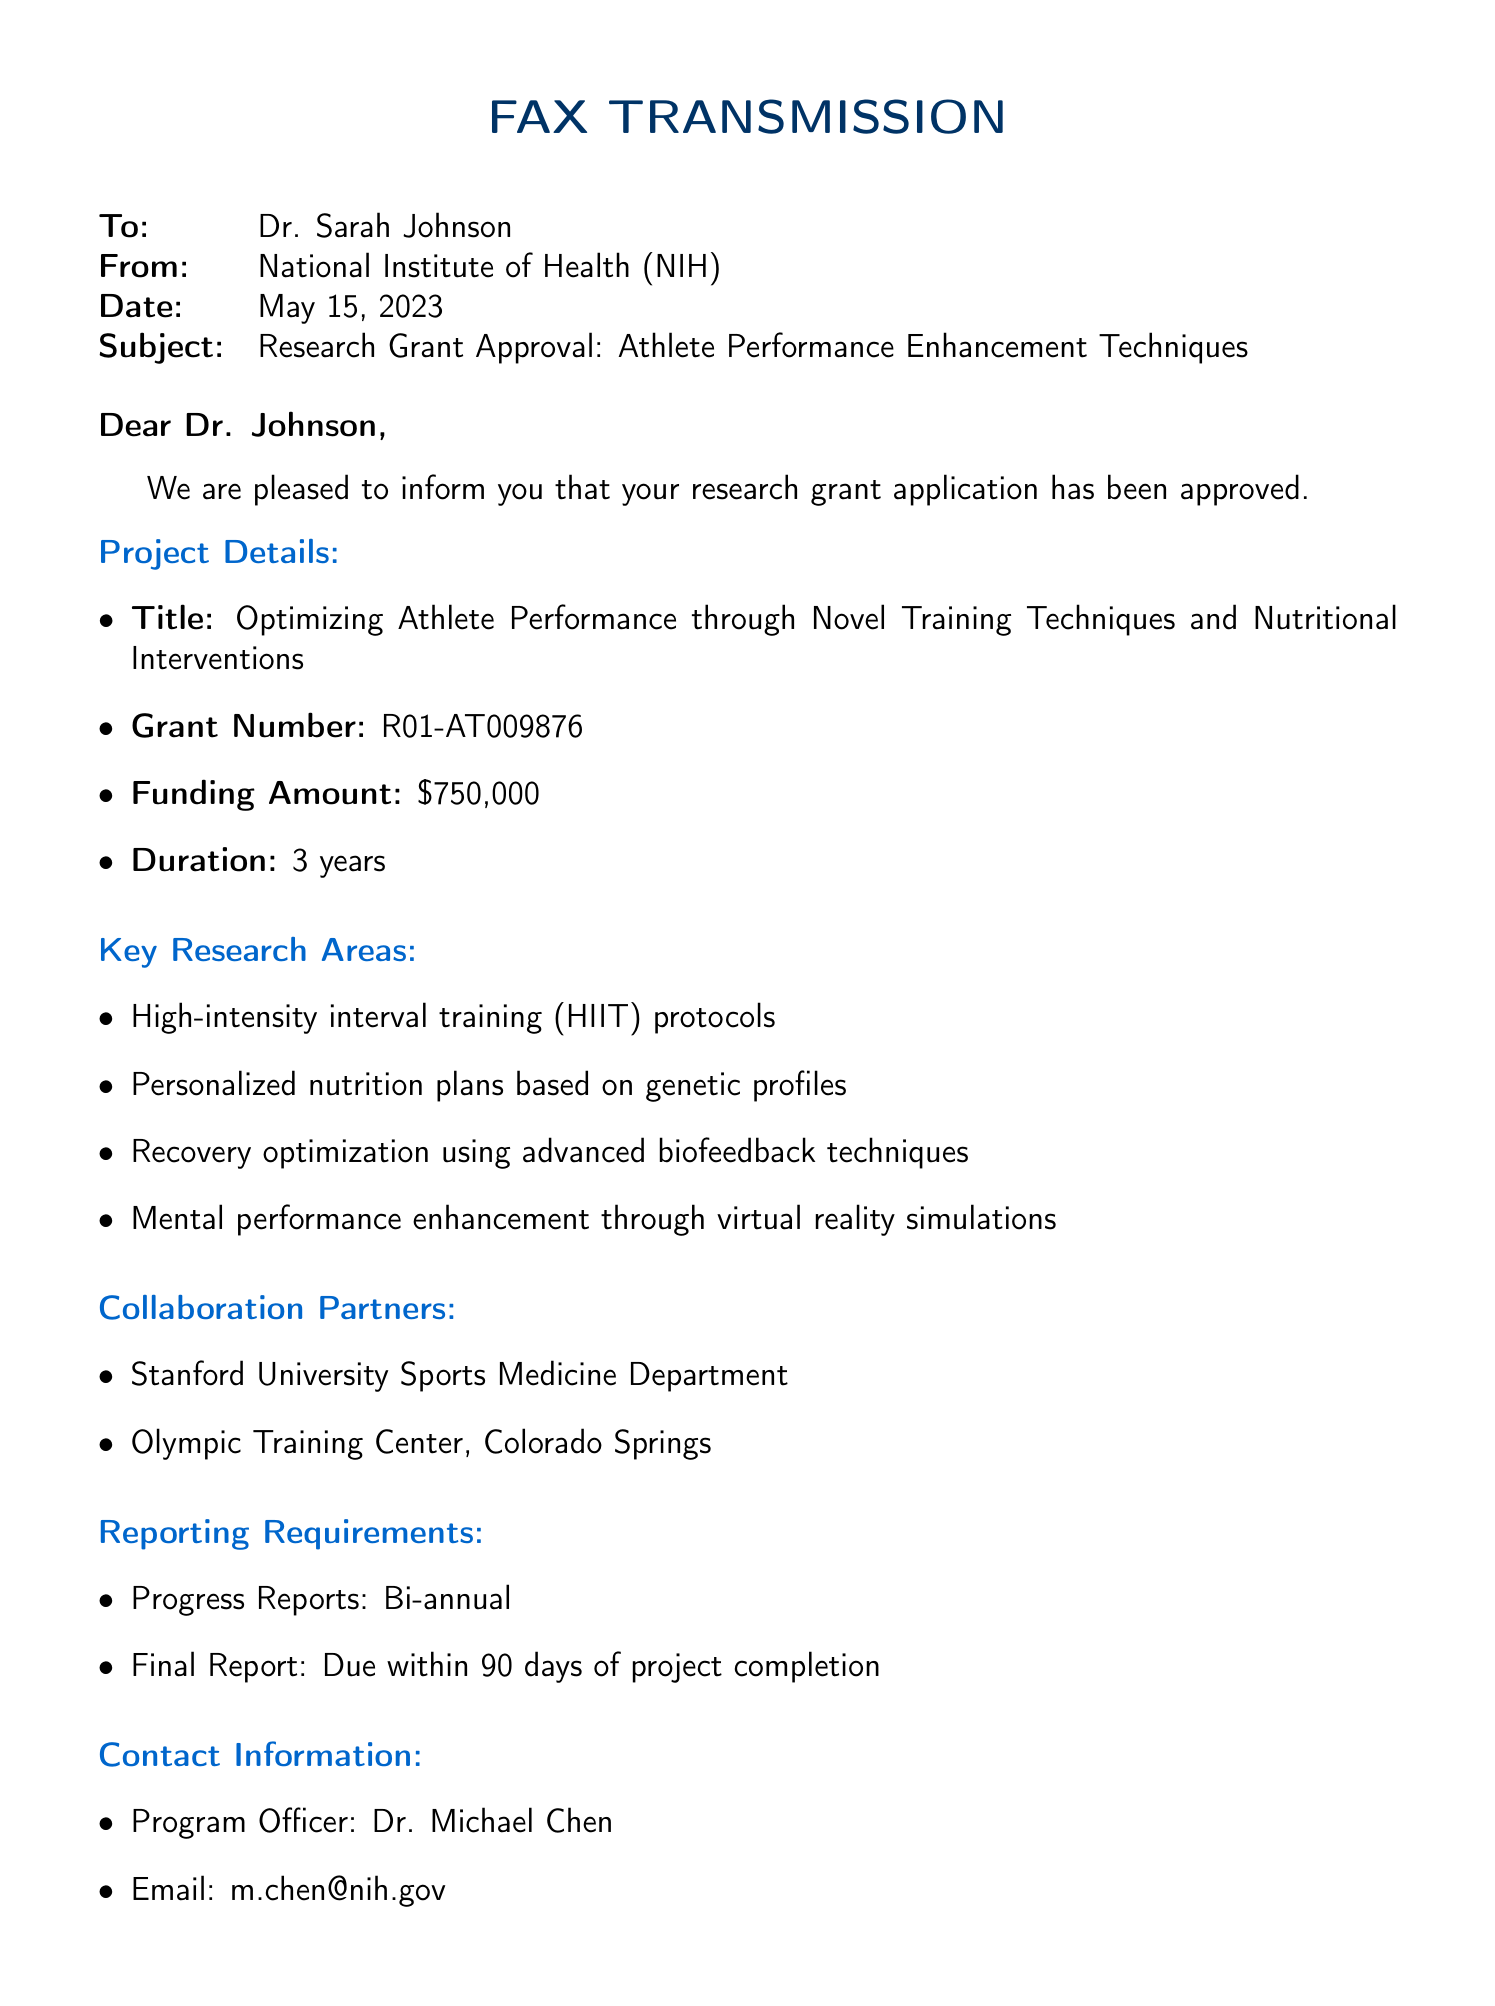What is the title of the research project? The title of the research project is stated in the project details section of the fax.
Answer: Optimizing Athlete Performance through Novel Training Techniques and Nutritional Interventions What is the grant number? The grant number is listed under project details in the document.
Answer: R01-AT009876 How much funding has been approved? The funding amount is specified in the project details section of the fax.
Answer: $750,000 What is the duration of the project? The duration is mentioned in the project details, indicating how long the funding is allocated.
Answer: 3 years What are two key research areas mentioned? The document lists multiple key research areas; selecting any two gives a valid answer.
Answer: High-intensity interval training (HIIT) protocols, Personalized nutrition plans based on genetic profiles Who are the collaboration partners? The collaboration partners are explicitly mentioned in a section of the fax.
Answer: Stanford University Sports Medicine Department, Olympic Training Center, Colorado Springs When are the progress reports due? The document specifies the frequency of progress reports under reporting requirements.
Answer: Bi-annual What is the next step after receiving this approval? The document outlines next steps in the concluding section, which includes actions to be taken.
Answer: Sign and return the attached grant agreement within 14 days 